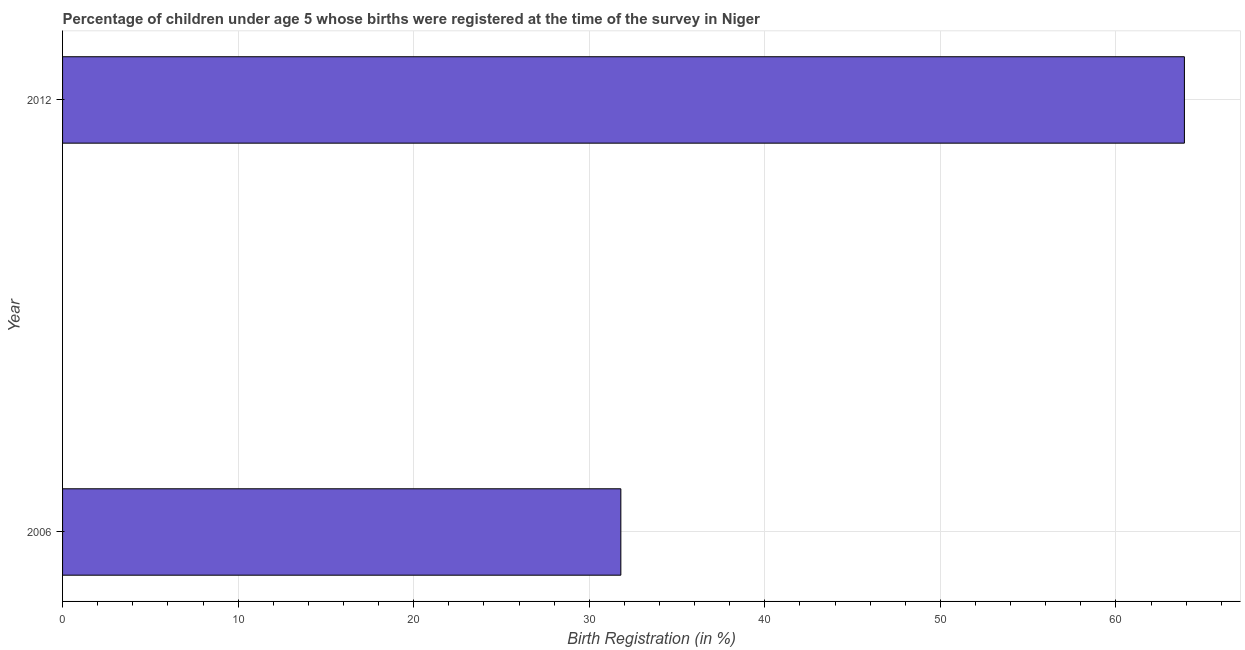What is the title of the graph?
Keep it short and to the point. Percentage of children under age 5 whose births were registered at the time of the survey in Niger. What is the label or title of the X-axis?
Your response must be concise. Birth Registration (in %). What is the birth registration in 2006?
Offer a terse response. 31.8. Across all years, what is the maximum birth registration?
Your answer should be compact. 63.9. Across all years, what is the minimum birth registration?
Give a very brief answer. 31.8. In which year was the birth registration minimum?
Ensure brevity in your answer.  2006. What is the sum of the birth registration?
Ensure brevity in your answer.  95.7. What is the difference between the birth registration in 2006 and 2012?
Keep it short and to the point. -32.1. What is the average birth registration per year?
Your answer should be compact. 47.85. What is the median birth registration?
Offer a very short reply. 47.85. What is the ratio of the birth registration in 2006 to that in 2012?
Give a very brief answer. 0.5. Is the birth registration in 2006 less than that in 2012?
Your answer should be very brief. Yes. In how many years, is the birth registration greater than the average birth registration taken over all years?
Provide a short and direct response. 1. How many bars are there?
Offer a terse response. 2. What is the Birth Registration (in %) in 2006?
Your answer should be very brief. 31.8. What is the Birth Registration (in %) of 2012?
Offer a terse response. 63.9. What is the difference between the Birth Registration (in %) in 2006 and 2012?
Make the answer very short. -32.1. What is the ratio of the Birth Registration (in %) in 2006 to that in 2012?
Your answer should be very brief. 0.5. 